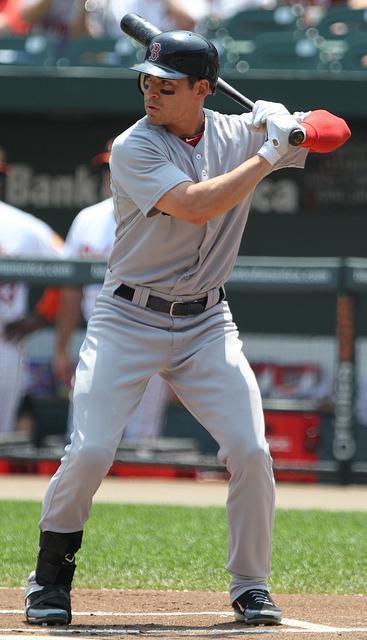How many people are visible?
Give a very brief answer. 3. How many bears are there?
Give a very brief answer. 0. 